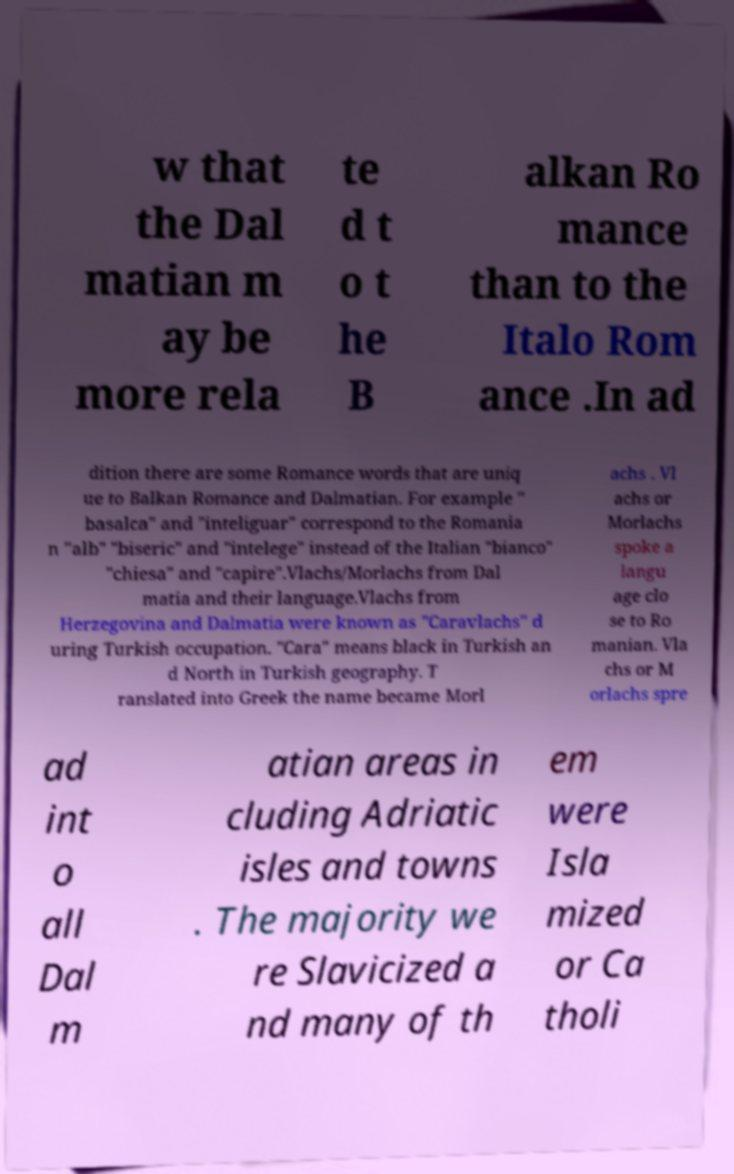Can you accurately transcribe the text from the provided image for me? w that the Dal matian m ay be more rela te d t o t he B alkan Ro mance than to the Italo Rom ance .In ad dition there are some Romance words that are uniq ue to Balkan Romance and Dalmatian. For example " basalca" and "inteliguar" correspond to the Romania n "alb" "biseric" and "intelege" instead of the Italian "bianco" "chiesa" and "capire".Vlachs/Morlachs from Dal matia and their language.Vlachs from Herzegovina and Dalmatia were known as "Caravlachs" d uring Turkish occupation. "Cara" means black in Turkish an d North in Turkish geography. T ranslated into Greek the name became Morl achs . Vl achs or Morlachs spoke a langu age clo se to Ro manian. Vla chs or M orlachs spre ad int o all Dal m atian areas in cluding Adriatic isles and towns . The majority we re Slavicized a nd many of th em were Isla mized or Ca tholi 